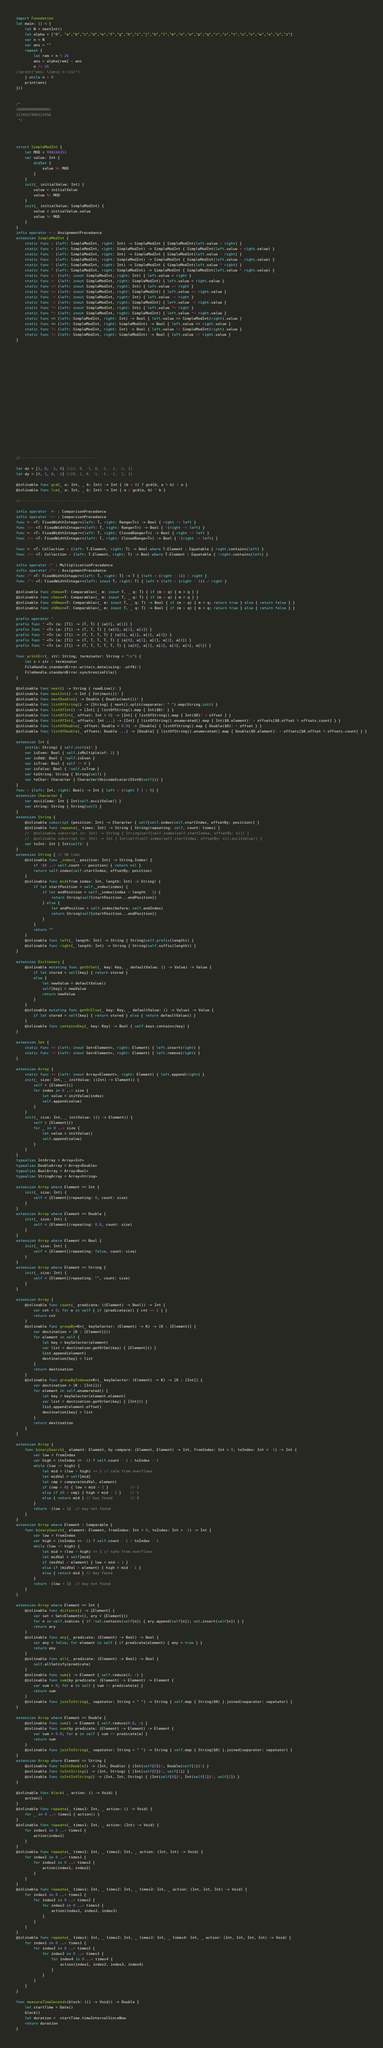<code> <loc_0><loc_0><loc_500><loc_500><_Swift_>





import Foundation
let main: () = {
    let N = nextInt()
    let alpha = ["0", "a","b","c","d","e","f","g","h","i","j","k","l","m","n","o","p","q","r","s","t","u","v","w","x","y","z"]
    var n = N
    var ans = ""
    repeat {
        let rem = n % 26
        ans = alpha[rem] + ans
        n /= 26
//print("ans: \(ans) n:\(n)")
    } while n > 0
    print(ans)
}()


/*
1000000000000001
1234567890123456
 */




struct SimpleModInt {
    let MOD = 998244353
    var value: Int {
        didSet {
            value %= MOD
        }
    }
    init(_ initialValue: Int) {
        value = initialValue
        value %= MOD
    }
    init(_ initialValue: SimpleModInt) {
        value = initialValue.value
        value %= MOD
    }
}
infix operator <-: AssignmentPrecedence
extension SimpleModInt {
    static func + (left: SimpleModInt, right: Int) -> SimpleModInt { SimpleModInt(left.value + right) }
    static func + (left: SimpleModInt, right: SimpleModInt) -> SimpleModInt { SimpleModInt(left.value + right.value) }
    static func - (left: SimpleModInt, right: Int) -> SimpleModInt { SimpleModInt(left.value - right) }
    static func - (left: SimpleModInt, right: SimpleModInt) -> SimpleModInt { SimpleModInt(left.value - right.value) }
    static func * (left: SimpleModInt, right: Int) -> SimpleModInt { SimpleModInt(left.value * right) }
    static func * (left: SimpleModInt, right: SimpleModInt) -> SimpleModInt { SimpleModInt(left.value * right.value) }
    static func <- (left: inout SimpleModInt, right: Int) { left.value = right }
    static func <- (left: inout SimpleModInt, right: SimpleModInt) { left.value = right.value }
    static func += (left: inout SimpleModInt, right: Int) { left.value += right }
    static func += (left: inout SimpleModInt, right: SimpleModInt) { left.value += right.value }
    static func -= (left: inout SimpleModInt, right: Int) { left.value -= right }
    static func -= (left: inout SimpleModInt, right: SimpleModInt) { left.value -= right.value }
    static func *= (left: inout SimpleModInt, right: Int) { left.value *= right }
    static func *= (left: inout SimpleModInt, right: SimpleModInt) { left.value *= right.value }
    static func == (left: SimpleModInt, right: Int) -> Bool { left.value == SimpleModInt(right).value }
    static func == (left: SimpleModInt, right: SimpleModInt) -> Bool { left.value == right.value }
    static func != (left: SimpleModInt, right: Int) -> Bool { left.value != SimpleModInt(right).value }
    static func != (left: SimpleModInt, right: SimpleModInt) -> Bool { left.value != right.value }
}





















//----------------------------------

let dx = [1, 0, -1, 0] //[1, 0, -1, 0, -1,  1, -1, 1]
let dy = [0, 1, 0, -1] //[0, 1, 0, -1, -1, -1,  1, 1]

@inlinable func gcd(_ a: Int, _ b: Int) -> Int { (b > 0) ? gcd(b, a % b) : a }
@inlinable func lcm(_ a: Int, _ b: Int) -> Int { a / gcd(a, b) * b }

//----------------------------------

infix operator  =~ : ComparisonPrecedence
infix operator !=~ : ComparisonPrecedence
func =~ <T: FixedWidthInteger>(left: T, right: Range<T>) -> Bool { right ~= left }
func !=~ <T: FixedWidthInteger>(left: T, right: Range<T>) -> Bool { !(right ~= left) }
func =~ <T: FixedWidthInteger>(left: T, right: ClosedRange<T>) -> Bool { right ~= left }
func !=~ <T: FixedWidthInteger>(left: T, right: ClosedRange<T>) -> Bool { !(right ~= left) }

func =~ <T: Collection > (left: T.Element, right: T) -> Bool where T.Element : Equatable { right.contains(left) }
func !=~ <T: Collection > (left: T.Element, right: T) -> Bool where T.Element : Equatable { !right.contains(left) }

infix operator /^ : MultiplicationPrecedence
infix operator /^= : AssignmentPrecedence
func /^ <T: FixedWidthInteger>(left: T, right: T) -> T { (left + (right - 1)) / right }
func /^= <T: FixedWidthInteger>(left: inout T, right: T) { left = (left + (right - 1)) / right }

@inlinable func chmax<T: Comparable>(_ m: inout T, _ q: T) { if (m < q) { m = q } }
@inlinable func chmin<T: Comparable>(_ m: inout T, _ q: T) { if (m > q) { m = q } }
@inlinable func chRmax<T: Comparable>(_ m: inout T, _ q: T) -> Bool { if (m < q) { m = q; return true } else { return false } }
@inlinable func chRmin<T: Comparable>(_ m: inout T, _ q: T) -> Bool { if (m > q) { m = q; return true } else { return false } }

prefix operator *
prefix func * <T> (a: [T]) -> (T, T) { (a[0], a[1]) }
prefix func * <T> (a: [T]) -> (T, T, T) { (a[0], a[1], a[2]) }
prefix func * <T> (a: [T]) -> (T, T, T, T) { (a[0], a[1], a[2], a[3]) }
prefix func * <T> (a: [T]) -> (T, T, T, T, T) { (a[0], a[1], a[2], a[3], a[4]) }
prefix func * <T> (a: [T]) -> (T, T, T, T, T, T) { (a[0], a[1], a[2], a[3], a[4], a[5]) }

func printErr(_ str: String, terminator: String = "\n") {
    let s = str + terminator
    FileHandle.standardError.write(s.data(using: .utf8)!)
    FileHandle.standardError.synchronizeFile()
}

@inlinable func next() -> String { readLine()! }
@inlinable func nextInt() -> Int { Int(next())! }
@inlinable func nextDouble() -> Double { Double(next())! }
@inlinable func listOfString() -> [String] { next().split(separator: " ").map(String.init) }
@inlinable func listOfInt() -> [Int] { listOfString().map { Int($0)! } }
@inlinable func listOfInt(_ offset: Int = 0) -> [Int] { listOfString().map { Int($0)! + offset } }
@inlinable func listOfInt(_ offsets: Int ...) -> [Int] { listOfString().enumerated().map { Int($0.element)! + offsets[$0.offset % offsets.count] } }
@inlinable func listOfDouble(_ offset: Double = 0.0) -> [Double] { listOfString().map { Double($0)! + offset } }
@inlinable func listOfDouble(_ offsets: Double ...) -> [Double] { listOfString().enumerated().map { Double($0.element)! + offsets[$0.offset % offsets.count] } }

extension Int {
    init(s: String) { self.init(s)! }
    var isEven: Bool { self.isMultiple(of: 2) }
    var isOdd: Bool { !self.isEven }
    var isTrue: Bool { self != 0 }
    var isFalse: Bool { !self.isTrue }
    var toString: String { String(self) }
    var toChar: Character { Character(UnicodeScalar(UInt8(self))) }
}
func + (left: Int, right: Bool) -> Int { left + (right ? 1 : 0) }
extension Character {
    var asciiCode: Int { Int(self.asciiValue!) }
    var string: String { String(self) }
}
extension String {
    @inlinable subscript (position: Int) -> Character { self[self.index(self.startIndex, offsetBy: position)] }
    @inlinable func repeate(_ times: Int) -> String { String(repeating: self, count: times) }
    //  @inlinable subscript (n: Int) -> String { String(self[self.index(self.startIndex, offsetBy: n)]) }
    //  @inlinable subscript (n: Int) -> Int { Int(self[self.index(self.startIndex, offsetBy: n)].asciiValue!) }
    var toInt: Int { Int(self)! }
}
extension String { // VB like
    @inlinable func _index(_ position: Int) -> String.Index! {
        if !(0 ..< self.count ~= position) { return nil }
        return self.index(self.startIndex, offsetBy: position)
    }
    @inlinable func mid(from index: Int, length: Int) -> String! {
        if let startPosition = self._index(index) {
            if let endPosition = self._index(index + length - 1) {
                return String(self[startPosition...endPosition])
            } else {
                let endPosition = self.index(before: self.endIndex)
                return String(self[startPosition...endPosition])
            }
        }
        return ""
    }
    @inlinable func left(_ length: Int) -> String { String(self.prefix(length)) }
    @inlinable func right(_ length: Int) -> String { String(self.suffix(length)) }
}

extension Dictionary {
    @inlinable mutating func getOrSet(_ key: Key, _ defaultValue: () -> Value) -> Value {
        if let stored = self[key] { return stored }
        else {
            let newValue = defaultValue()
            self[key] = newValue
            return newValue
        }
    }
    @inlinable mutating func getOrElse(_ key: Key, _ defaultValue: () -> Value) -> Value {
        if let stored = self[key] { return stored } else { return defaultValue() }
    }
    @inlinable func containsKey(_ key: Key) -> Bool { self.keys.contains(key) }
}

extension Set {
    static func += (left: inout Set<Element>, right: Element) { left.insert(right) }
    static func -= (left: inout Set<Element>, right: Element) { left.remove(right) }
}

extension Array {
    static func += (left: inout Array<Element>, right: Element) { left.append(right) }
    init(_ size: Int, _ initValue: ((Int) -> Element)) {
        self = [Element]()
        for index in 0 ..< size {
            let value = initValue(index)
            self.append(value)
        }
    }
    init(_ size: Int, _ initValue: (() -> Element)) {
        self = [Element]()
        for _ in 0 ..< size {
            let value = initValue()
            self.append(value)
        }
    }
}
typealias IntArray = Array<Int>
typealias DoubleArray = Array<Double>
typealias BoolArray = Array<Bool>
typealias StringArray = Array<String>

extension Array where Element == Int {
    init(_ size: Int) {
        self = [Element](repeating: 0, count: size)
    }
}
extension Array where Element == Double {
    init(_ size: Int) {
        self = [Element](repeating: 0.0, count: size)
    }
}
extension Array where Element == Bool {
    init(_ size: Int) {
        self = [Element](repeating: false, count: size)
    }
}
extension Array where Element == String {
    init(_ size: Int) {
        self = [Element](repeating: "", count: size)
    }
}

extension Array {
    @inlinable func count(_ predicate: ((Element) -> Bool)) -> Int {
        var cnt = 0; for e in self { if (predicate(e)) { cnt += 1 } }
        return cnt
    }
    @inlinable func groupBy<K>(_ keySelector: (Element) -> K) -> [K : [Element]] {
        var destination = [K : [Element]]()
        for element in self {
            let key = keySelector(element)
            var list = destination.getOrSet(key) { [Element]() }
            list.append(element)
            destination[key] = list
        }
        return destination
    }
    @inlinable func groupByIndexed<K>(_ keySelector: (Element) -> K) -> [K : [Int]] {
        var destination = [K : [Int]]()
        for element in self.enumerated() {
            let key = keySelector(element.element)
            var list = destination.getOrSet(key) { [Int]() }
            list.append(element.offset)
            destination[key] = list
        }
        return destination
    }
}

extension Array {
    func binarySearch(_ element: Element, by compare: (Element, Element) -> Int, fromIndex: Int = 0, toIndex: Int = -1) -> Int {
        var low = fromIndex
        var high = (toIndex == -1) ? self.count - 1 : toIndex - 1
        while (low <= high) {
            let mid = (low + high) >> 1 // safe from overflows
            let midVal = self[mid]
            let cmp = compare(midVal, element)
            if (cmp < 0) { low = mid + 1 }          //-1
            else if (0 < cmp) { high = mid - 1 }    // 1
            else { return mid } // key found        // 0
        }
        return -(low + 1)  // key not found
    }
}
extension Array where Element : Comparable {
    func binarySearch(_ element: Element, fromIndex: Int = 0, toIndex: Int = -1) -> Int {
        var low = fromIndex
        var high = (toIndex == -1) ? self.count - 1 : toIndex - 1
        while (low <= high) {
            let mid = (low + high) >> 1 // safe from overflows
            let midVal = self[mid]
            if (midVal < element) { low = mid + 1 }
            else if (midVal > element) { high = mid - 1 }
            else { return mid } // key found
        }
        return -(low + 1)  // key not found
    }
}

extension Array where Element == Int {
    @inlinable func distinct() -> [Element] {
        var set = Set<Element>(), ary = [Element]()
        for n in self.indices { if !set.contains(self[n]) { ary.append(self[n]); set.insert(self[n]) } }
        return ary
    }
    @inlinable func any(_ predicate: (Element) -> Bool) -> Bool {
        var any = false; for element in self { if predicate(element) { any = true } }
        return any
    }
    @inlinable func all(_ predicate: (Element) -> Bool) -> Bool {
        self.allSatisfy(predicate)
    }
    @inlinable func sum() -> Element { self.reduce(0, +) }
    @inlinable func sum(by predicate: (Element) -> Element) -> Element {
        var sum = 0; for e in self { sum += predicate(e) }
        return sum
    }
    @inlinable func joinToString(_ sepatator: String = " ") -> String { self.map { String($0) }.joined(separator: sepatator) }
}

extension Array where Element == Double {
    @inlinable func sum() -> Element { self.reduce(0.0, +) }
    @inlinable func sum(by predicate: (Element) -> Element) -> Element {
        var sum = 0.0; for e in self { sum += predicate(e) }
        return sum
    }
    @inlinable func joinToString(_ sepatator: String = " ") -> String { self.map { String($0) }.joined(separator: sepatator) }
}
extension Array where Element == String {
    @inlinable func toIntDouble() -> (Int, Double) { (Int(self[0])!, Double(self[1])!) }
    @inlinable func toIntString() -> (Int, String) { (Int(self[0])!, self[1]) }
    @inlinable func toIntIntString() -> (Int, Int, String) { (Int(self[0])!, Int(self[1])!, self[2]) }
}

@inlinable func block( _ action: () -> Void) {
    action()
}
@inlinable func repeate(_ times1: Int, _ action: () -> Void) {
    for _ in 0 ..< times1 { action() }
}
@inlinable func repeate(_ times1: Int, _ action: (Int) -> Void) {
    for index1 in 0 ..< times1 {
        action(index1)
    }
}
@inlinable func repeate(_ times1: Int, _ times2: Int, _ action: (Int, Int) -> Void) {
    for index1 in 0 ..< times1 {
        for index2 in 0 ..< times2 {
            action(index1, index2)
        }
    }
}
@inlinable func repeate(_ times1: Int, _ times2: Int, _ times3: Int, _ action: (Int, Int, Int) -> Void) {
    for index1 in 0 ..< times1 {
        for index2 in 0 ..< times2 {
            for index3 in 0 ..< times3 {
                action(index1, index2, index3)
            }
        }
    }
}
@inlinable func repeate(_ times1: Int, _ times2: Int, _ times3: Int, _ times4: Int, _ action: (Int, Int, Int, Int) -> Void) {
    for index1 in 0 ..< times1 {
        for index2 in 0 ..< times2 {
            for index3 in 0 ..< times3 {
                for index4 in 0 ..< times4 {
                    action(index1, index2, index3, index4)
                }
            }
        }
    }
}

func measureTimeSeconds(block: (() -> Void)) -> Double {
    let startTime = Date()
    block()
    let duration = -startTime.timeIntervalSinceNow
    return duration
}
</code> 